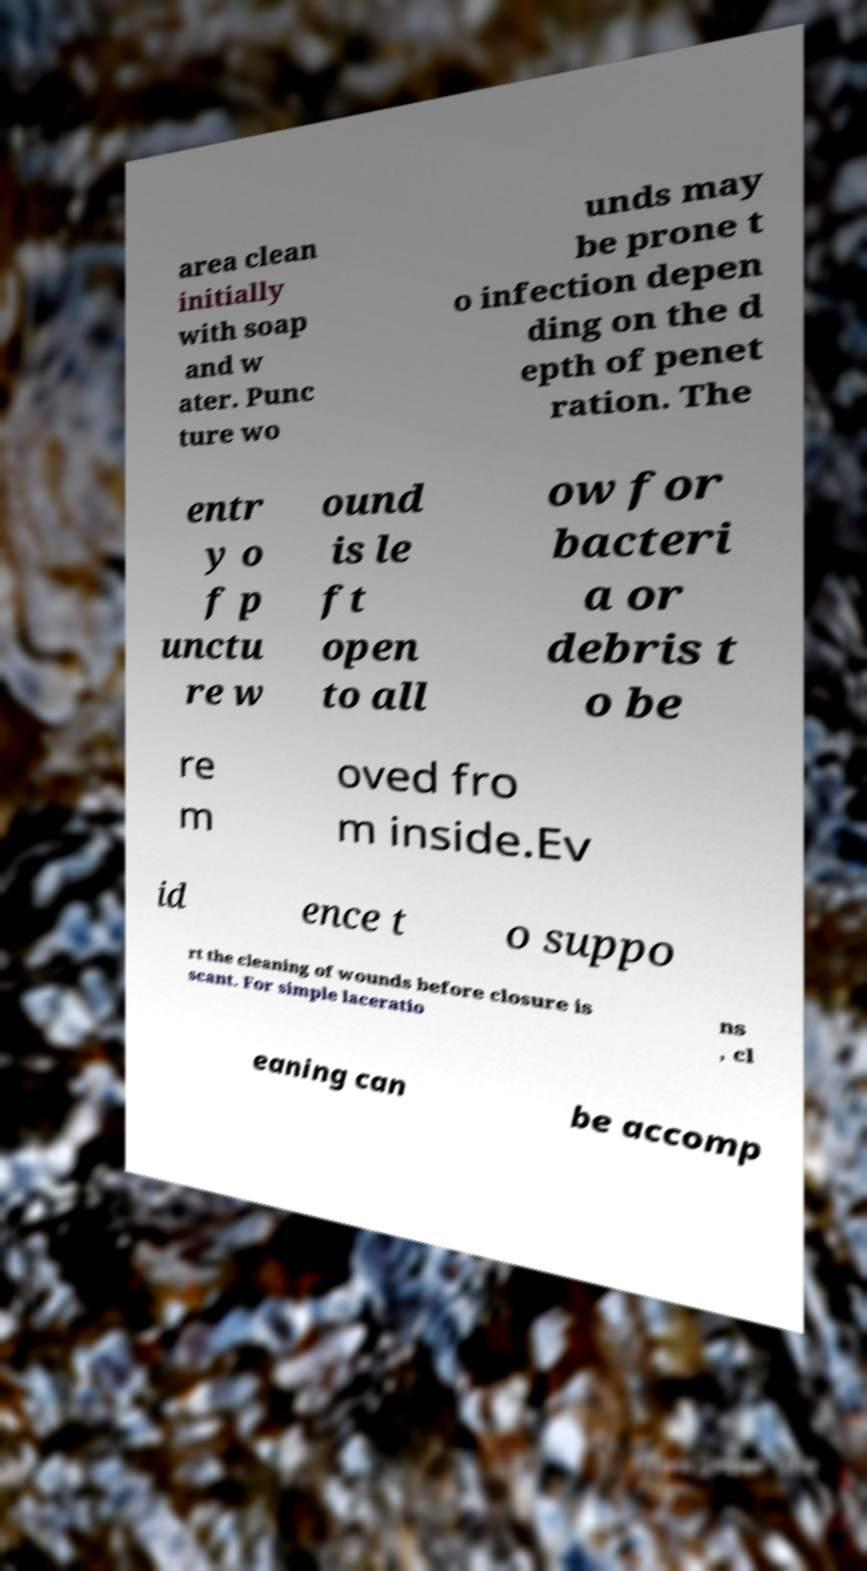What messages or text are displayed in this image? I need them in a readable, typed format. area clean initially with soap and w ater. Punc ture wo unds may be prone t o infection depen ding on the d epth of penet ration. The entr y o f p unctu re w ound is le ft open to all ow for bacteri a or debris t o be re m oved fro m inside.Ev id ence t o suppo rt the cleaning of wounds before closure is scant. For simple laceratio ns , cl eaning can be accomp 